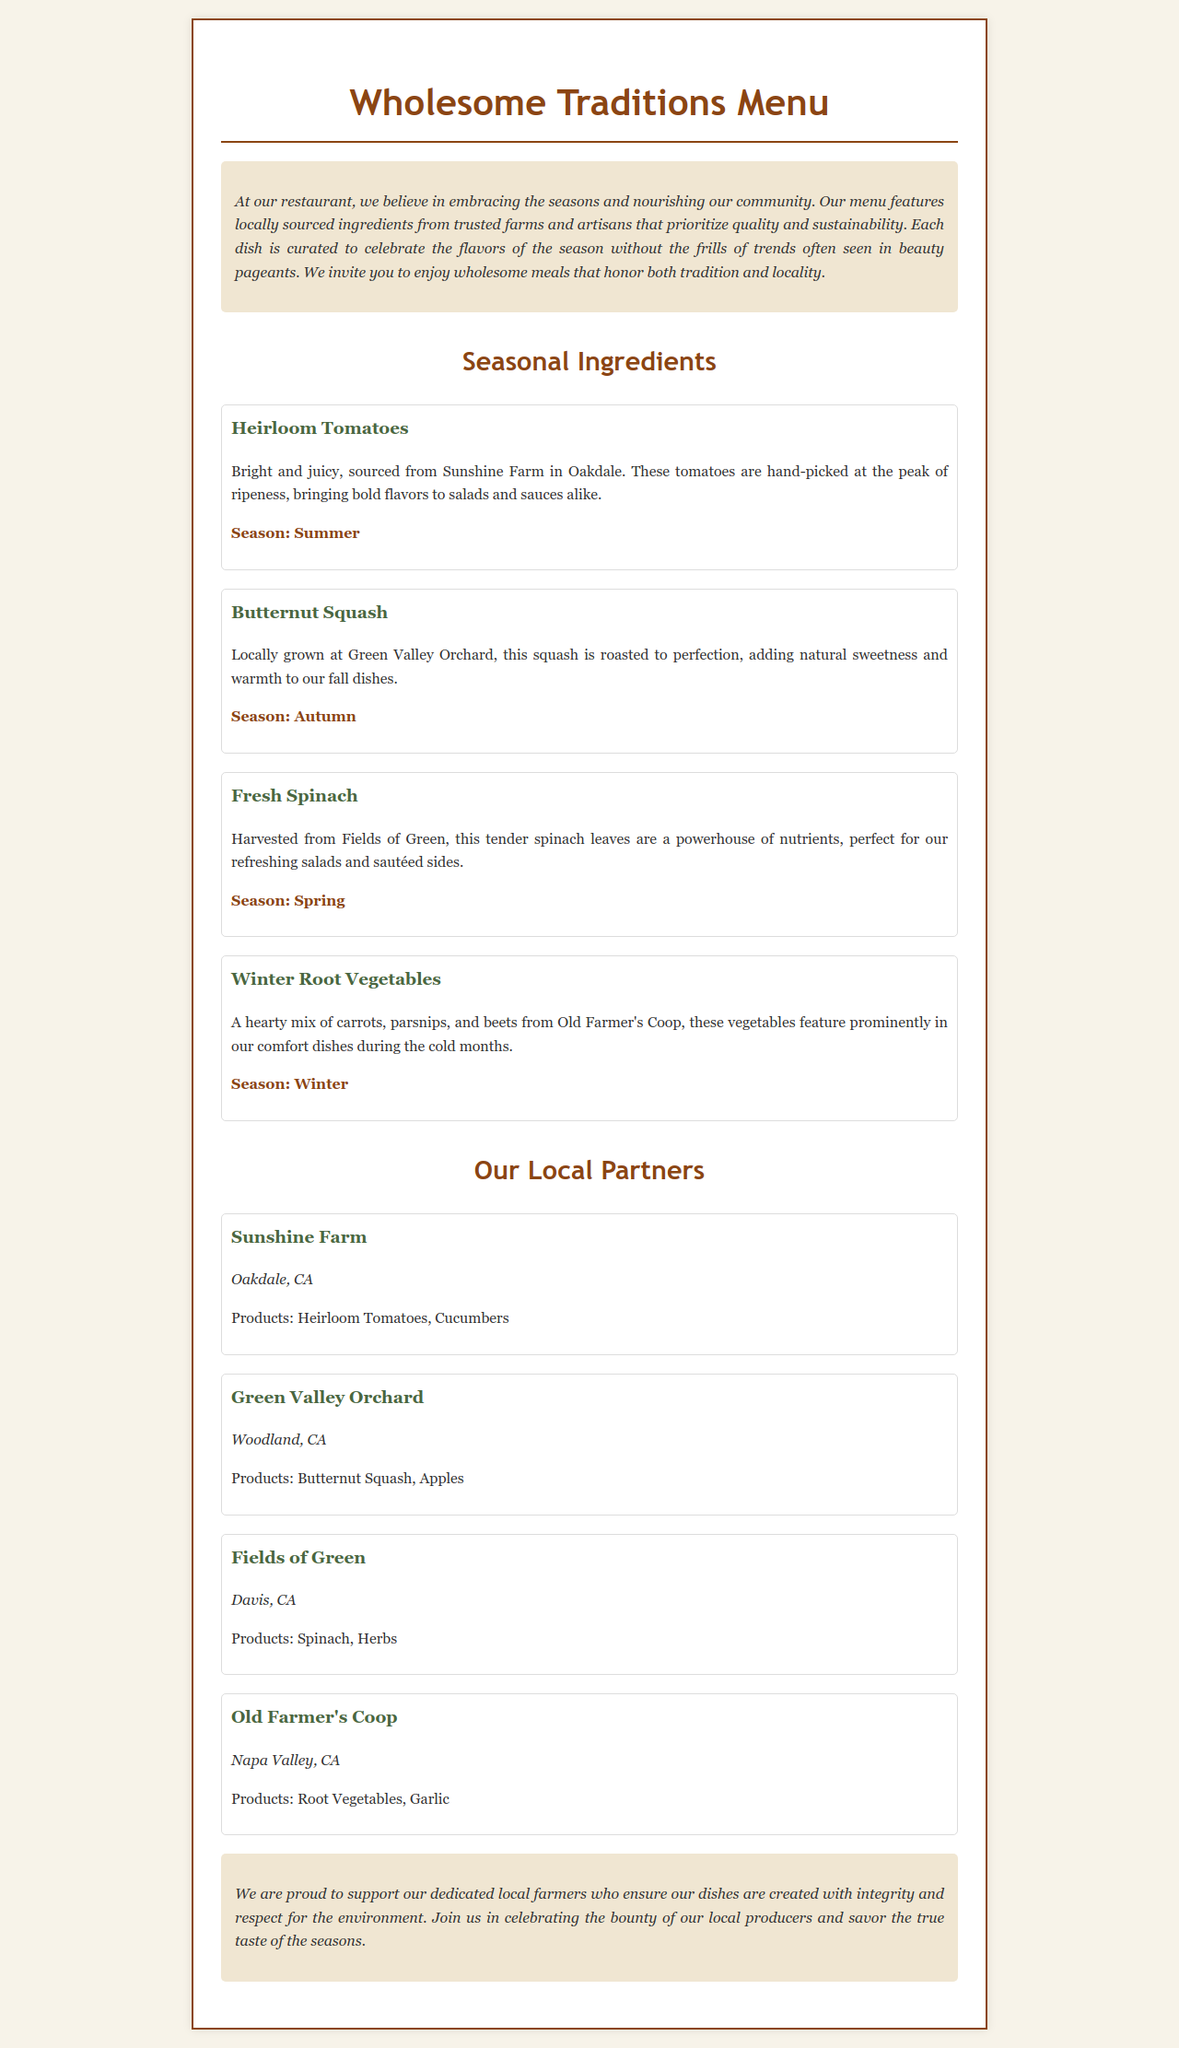What is the title of the menu? The title of the menu is prominently displayed at the top of the document as "Wholesome Traditions Menu."
Answer: Wholesome Traditions Menu Which farm supplies heirloom tomatoes? The document lists "Sunshine Farm" as the supplier of heirloom tomatoes, located in Oakdale, CA.
Answer: Sunshine Farm What season is butternut squash served? The document specifies that butternut squash is available in the autumn season.
Answer: Autumn How many farms are mentioned in the document? The menu lists a total of four farms that provide local ingredients: Sunshine Farm, Green Valley Orchard, Fields of Green, and Old Farmer's Coop.
Answer: Four What product is associated with Fields of Green? The document states that Fields of Green supplies spinach and herbs.
Answer: Spinach Which vegetables are featured in winter dishes? According to the menu, winter root vegetables include carrots, parsnips, and beets from Old Farmer's Coop.
Answer: Carrots, parsnips, and beets Where is Green Valley Orchard located? The document indicates that Green Valley Orchard is located in Woodland, CA.
Answer: Woodland, CA What type of ingredient is fresh spinach categorized as? Fresh spinach is categorized as a seasonal ingredient in the spring season.
Answer: Seasonal ingredient What kind of meals does the restaurant emphasize? The menu highlights that the restaurant emphasizes wholesome meals that honor tradition and locality.
Answer: Wholesome meals 